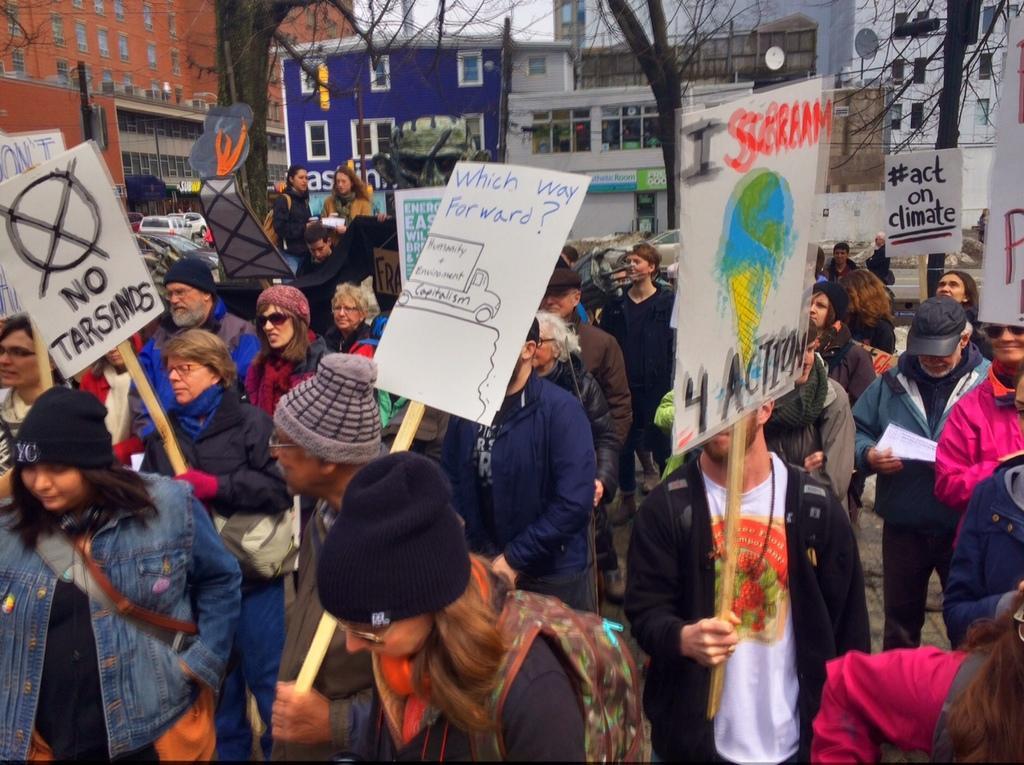Can you describe this image briefly? At the top of the image we can see buildings, trees and sky. At the bottom of the image we can see persons standing on the road by holding placards in their hands, motor vehicles and sign boards. 